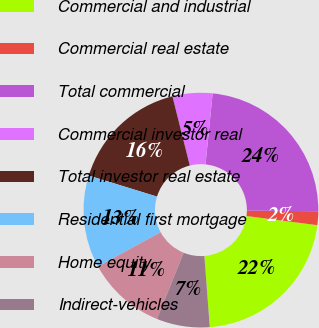<chart> <loc_0><loc_0><loc_500><loc_500><pie_chart><fcel>Commercial and industrial<fcel>Commercial real estate<fcel>Total commercial<fcel>Commercial investor real<fcel>Total investor real estate<fcel>Residential first mortgage<fcel>Home equity<fcel>Indirect-vehicles<nl><fcel>21.76%<fcel>1.89%<fcel>23.56%<fcel>5.5%<fcel>16.34%<fcel>12.73%<fcel>10.92%<fcel>7.31%<nl></chart> 